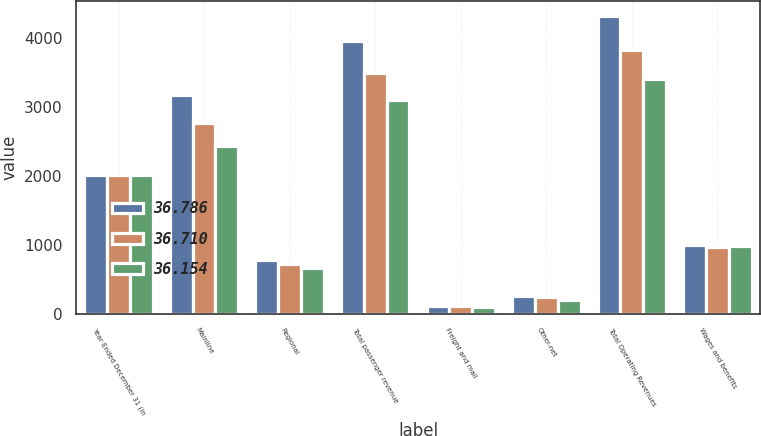<chart> <loc_0><loc_0><loc_500><loc_500><stacked_bar_chart><ecel><fcel>Year Ended December 31 (in<fcel>Mainline<fcel>Regional<fcel>Total passenger revenue<fcel>Freight and mail<fcel>Other-net<fcel>Total Operating Revenues<fcel>Wages and benefits<nl><fcel>36.786<fcel>2011<fcel>3176.2<fcel>774.5<fcel>3950.7<fcel>108.7<fcel>258.4<fcel>4317.8<fcel>990.5<nl><fcel>36.71<fcel>2010<fcel>2763.4<fcel>725.2<fcel>3488.6<fcel>106.2<fcel>237.5<fcel>3832.3<fcel>960.9<nl><fcel>36.154<fcel>2009<fcel>2438.8<fcel>668.6<fcel>3107.4<fcel>95.9<fcel>196.5<fcel>3399.8<fcel>988.1<nl></chart> 